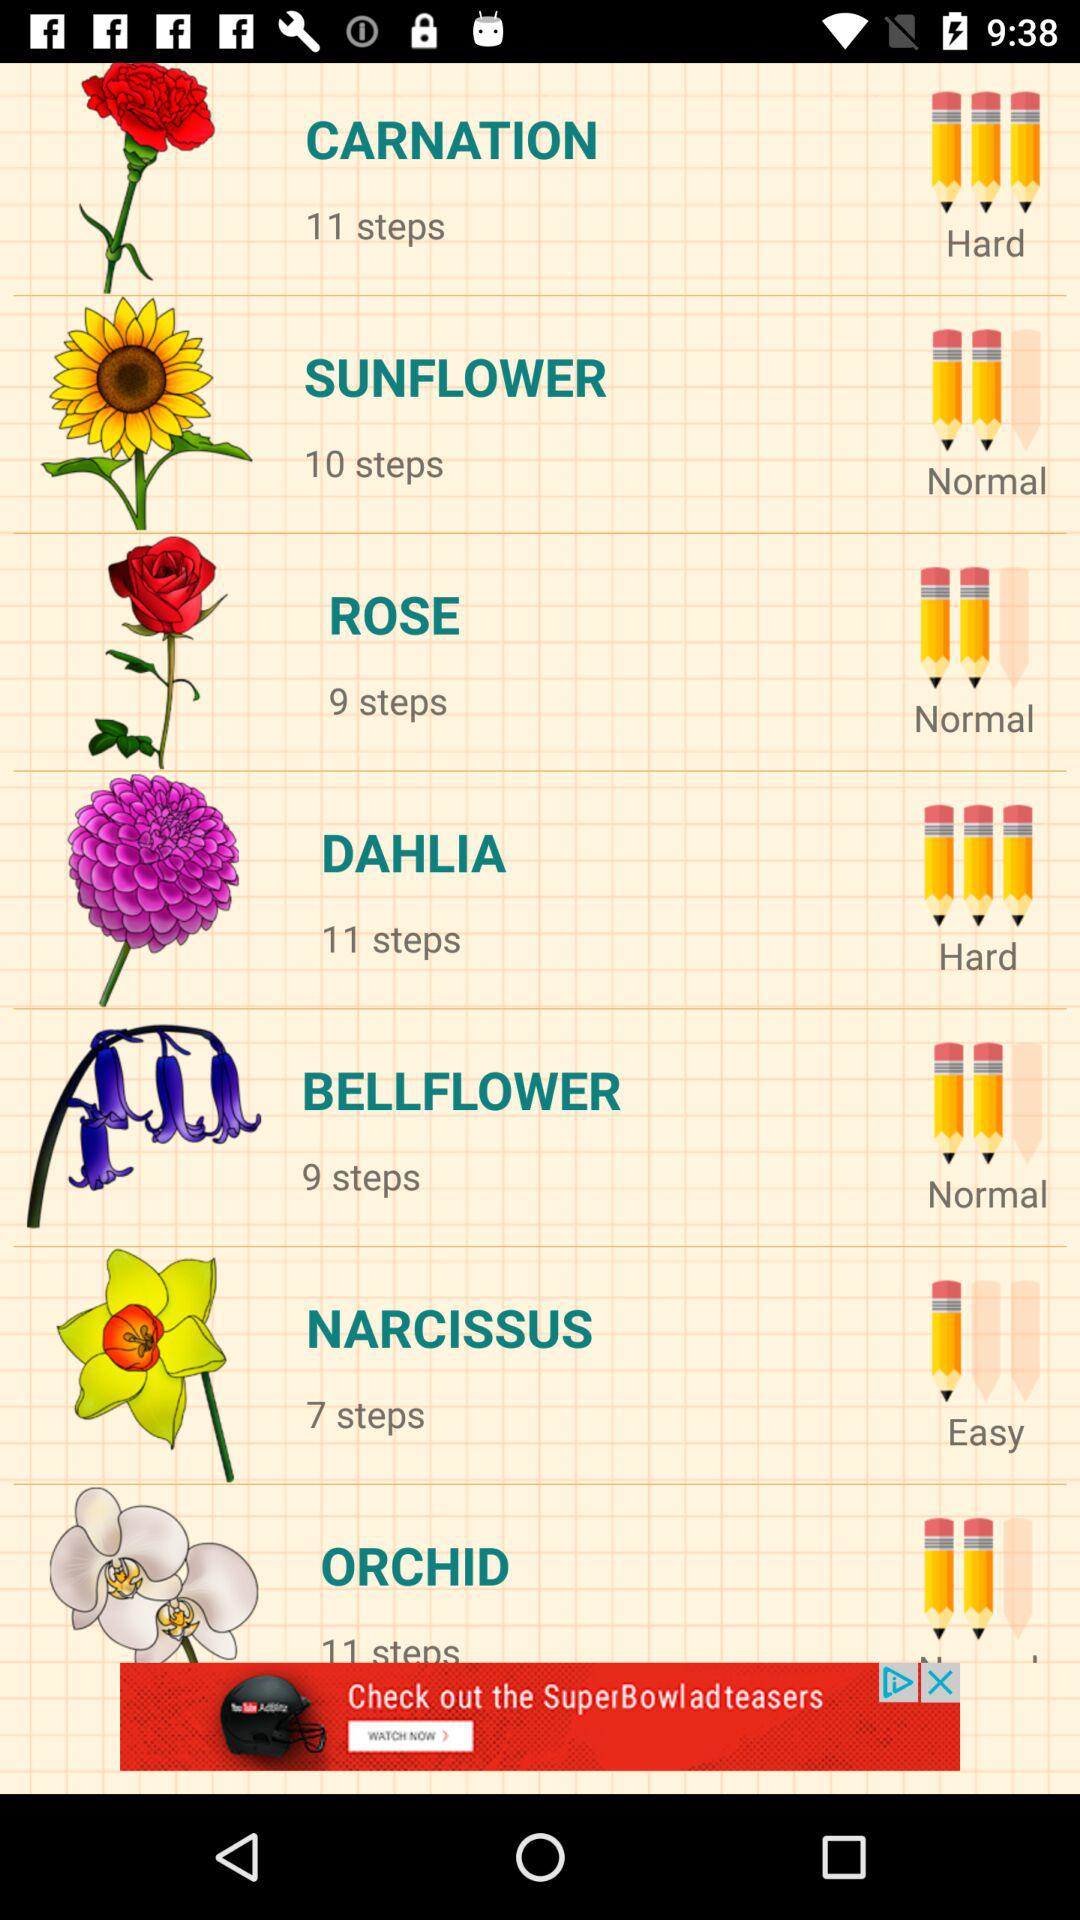How many steps will it take to draw "DAHLIA"? It will take 11 steps to draw "DAHLIA". 